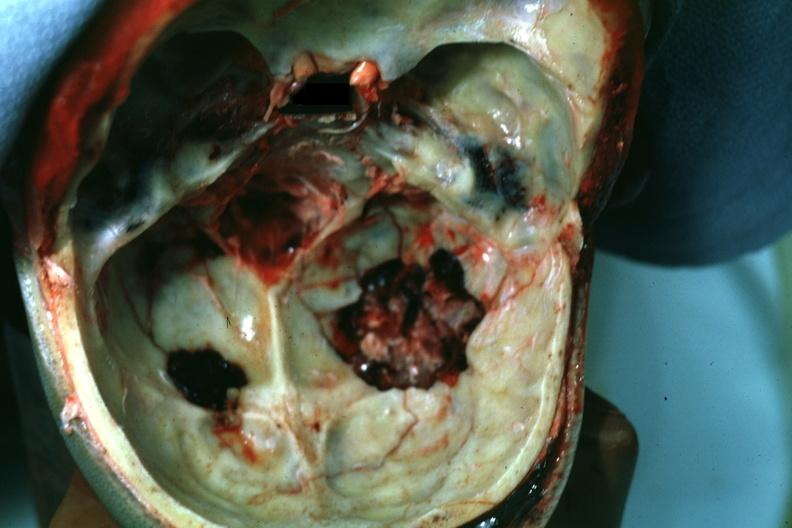s leiomyoma present?
Answer the question using a single word or phrase. No 